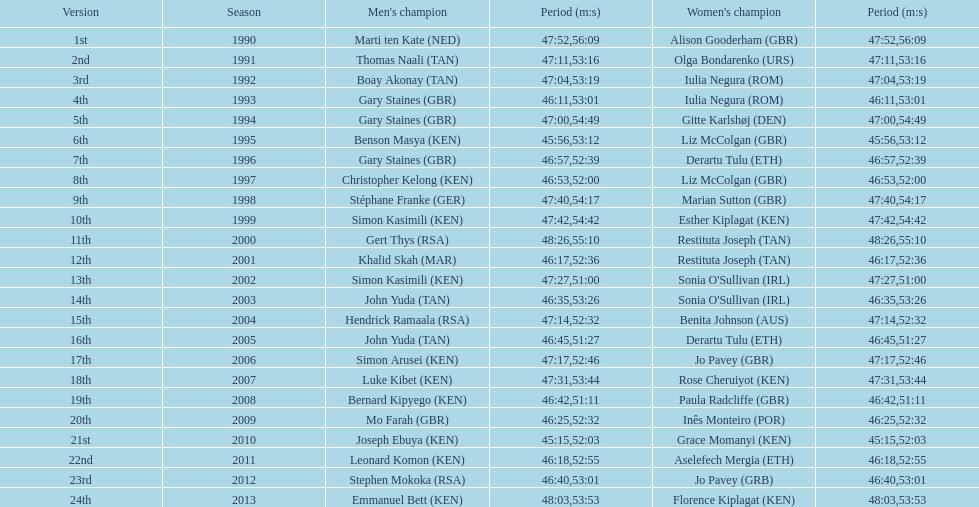What is the title of the initial female victor? Alison Gooderham. 